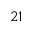Convert formula to latex. <formula><loc_0><loc_0><loc_500><loc_500>2 1</formula> 